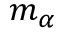<formula> <loc_0><loc_0><loc_500><loc_500>m _ { \alpha }</formula> 